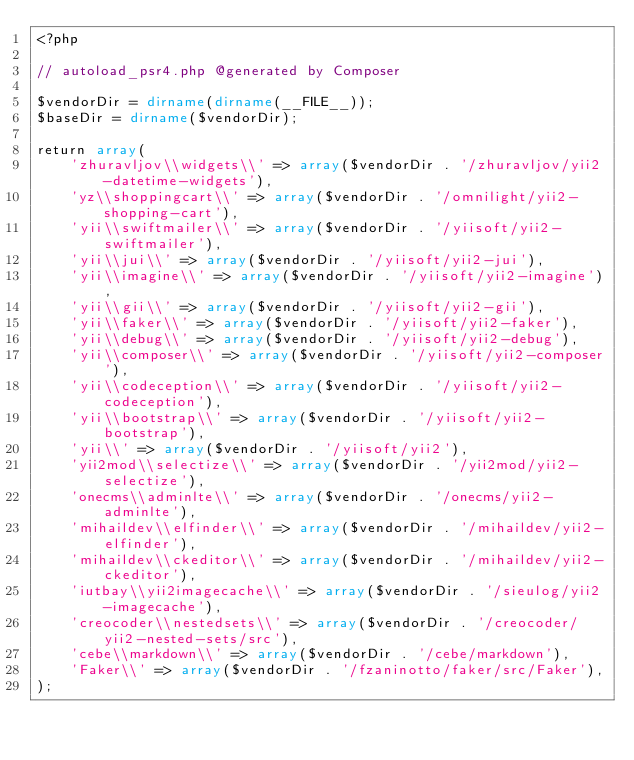<code> <loc_0><loc_0><loc_500><loc_500><_PHP_><?php

// autoload_psr4.php @generated by Composer

$vendorDir = dirname(dirname(__FILE__));
$baseDir = dirname($vendorDir);

return array(
    'zhuravljov\\widgets\\' => array($vendorDir . '/zhuravljov/yii2-datetime-widgets'),
    'yz\\shoppingcart\\' => array($vendorDir . '/omnilight/yii2-shopping-cart'),
    'yii\\swiftmailer\\' => array($vendorDir . '/yiisoft/yii2-swiftmailer'),
    'yii\\jui\\' => array($vendorDir . '/yiisoft/yii2-jui'),
    'yii\\imagine\\' => array($vendorDir . '/yiisoft/yii2-imagine'),
    'yii\\gii\\' => array($vendorDir . '/yiisoft/yii2-gii'),
    'yii\\faker\\' => array($vendorDir . '/yiisoft/yii2-faker'),
    'yii\\debug\\' => array($vendorDir . '/yiisoft/yii2-debug'),
    'yii\\composer\\' => array($vendorDir . '/yiisoft/yii2-composer'),
    'yii\\codeception\\' => array($vendorDir . '/yiisoft/yii2-codeception'),
    'yii\\bootstrap\\' => array($vendorDir . '/yiisoft/yii2-bootstrap'),
    'yii\\' => array($vendorDir . '/yiisoft/yii2'),
    'yii2mod\\selectize\\' => array($vendorDir . '/yii2mod/yii2-selectize'),
    'onecms\\adminlte\\' => array($vendorDir . '/onecms/yii2-adminlte'),
    'mihaildev\\elfinder\\' => array($vendorDir . '/mihaildev/yii2-elfinder'),
    'mihaildev\\ckeditor\\' => array($vendorDir . '/mihaildev/yii2-ckeditor'),
    'iutbay\\yii2imagecache\\' => array($vendorDir . '/sieulog/yii2-imagecache'),
    'creocoder\\nestedsets\\' => array($vendorDir . '/creocoder/yii2-nested-sets/src'),
    'cebe\\markdown\\' => array($vendorDir . '/cebe/markdown'),
    'Faker\\' => array($vendorDir . '/fzaninotto/faker/src/Faker'),
);
</code> 